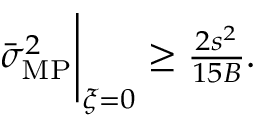Convert formula to latex. <formula><loc_0><loc_0><loc_500><loc_500>\begin{array} { r } { \bar { \sigma } _ { M P } ^ { 2 } \Big | _ { { \boldsymbol \xi } = 0 } \geq \frac { 2 s ^ { 2 } } { 1 5 B } . } \end{array}</formula> 